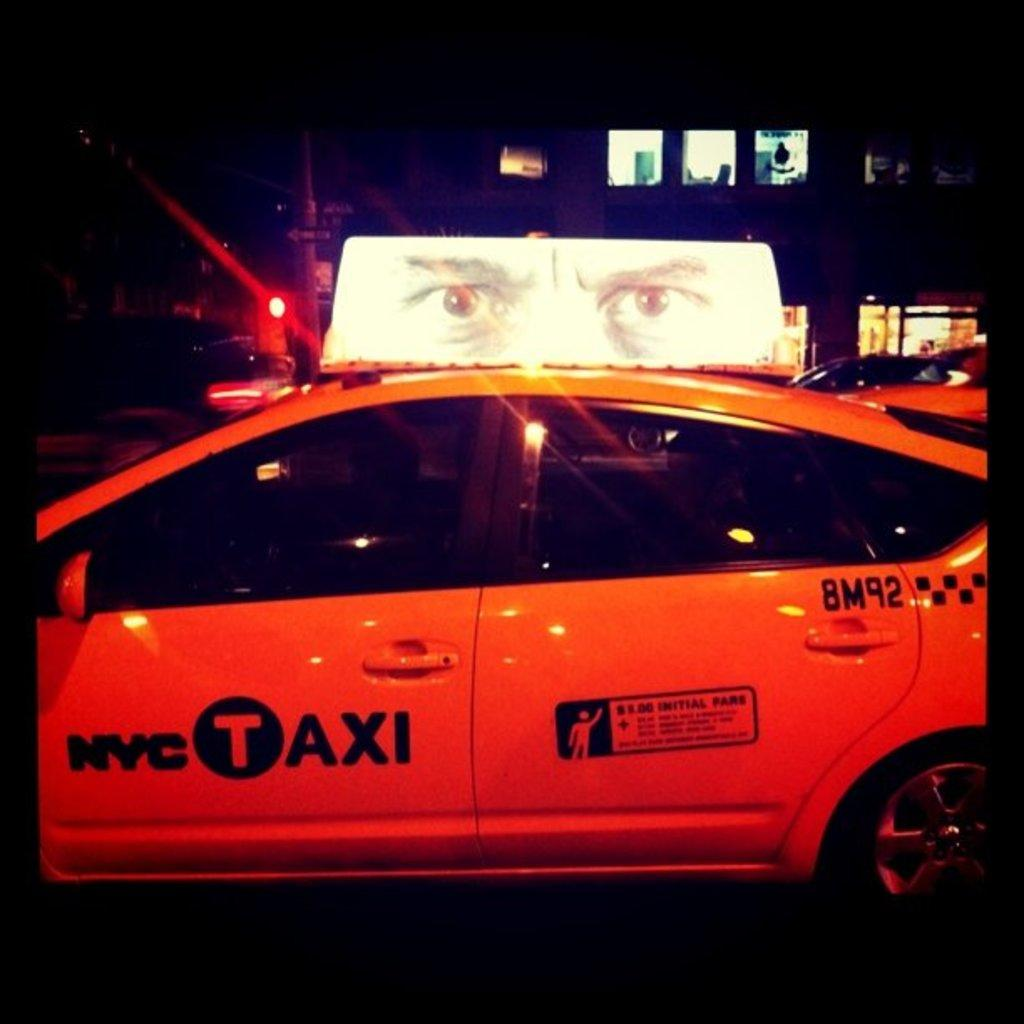<image>
Give a short and clear explanation of the subsequent image. A New York City taxi bears the number 8M92 on its rear door. 